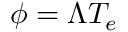<formula> <loc_0><loc_0><loc_500><loc_500>\phi = \Lambda T _ { e }</formula> 